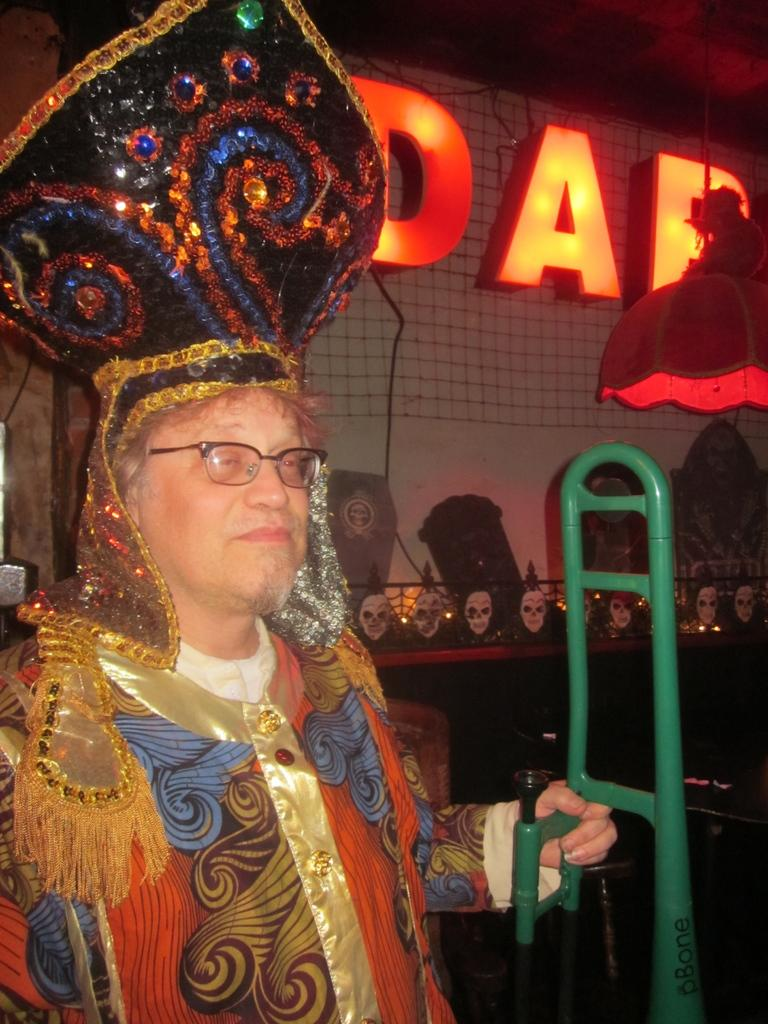Who is present in the image? There is a man in the image. What is the man wearing? The man is wearing clothes, spectacles, and a decorative crown. What type of object can be seen in the image that is made of metal? There is a metal object in the image, and it is green in color. What type of lighting device is present in the image? There is a lamp in the image. What type of text is visible in the image? There is LED text in the image. What type of argument is taking place between the man and the kettle in the image? There is no kettle present in the image, so no argument can be observed. What type of wax is being used to create the decorative crown in the image? There is no information about the materials used to create the decorative crown in the image. 